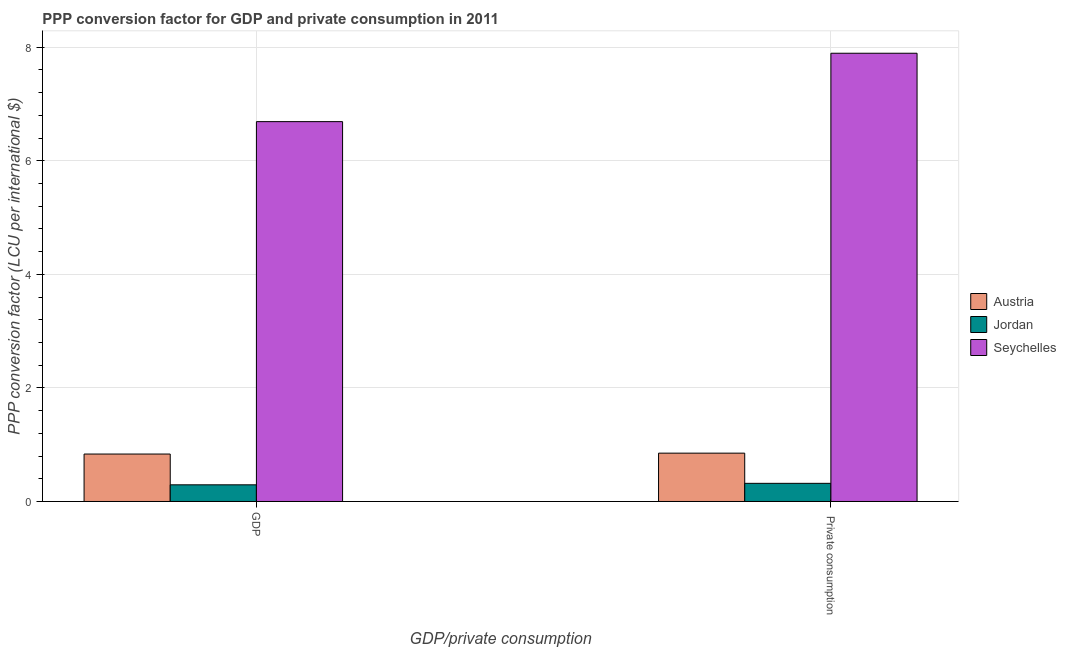How many different coloured bars are there?
Offer a very short reply. 3. Are the number of bars on each tick of the X-axis equal?
Make the answer very short. Yes. How many bars are there on the 2nd tick from the left?
Provide a short and direct response. 3. How many bars are there on the 1st tick from the right?
Provide a succinct answer. 3. What is the label of the 2nd group of bars from the left?
Your answer should be compact.  Private consumption. What is the ppp conversion factor for private consumption in Seychelles?
Make the answer very short. 7.9. Across all countries, what is the maximum ppp conversion factor for private consumption?
Offer a very short reply. 7.9. Across all countries, what is the minimum ppp conversion factor for gdp?
Offer a very short reply. 0.29. In which country was the ppp conversion factor for gdp maximum?
Provide a succinct answer. Seychelles. In which country was the ppp conversion factor for gdp minimum?
Keep it short and to the point. Jordan. What is the total ppp conversion factor for private consumption in the graph?
Offer a very short reply. 9.07. What is the difference between the ppp conversion factor for gdp in Jordan and that in Seychelles?
Ensure brevity in your answer.  -6.4. What is the difference between the ppp conversion factor for gdp in Jordan and the ppp conversion factor for private consumption in Seychelles?
Keep it short and to the point. -7.6. What is the average ppp conversion factor for private consumption per country?
Give a very brief answer. 3.02. What is the difference between the ppp conversion factor for private consumption and ppp conversion factor for gdp in Jordan?
Provide a short and direct response. 0.03. What is the ratio of the ppp conversion factor for private consumption in Austria to that in Seychelles?
Make the answer very short. 0.11. What does the 1st bar from the right in GDP represents?
Your response must be concise. Seychelles. How many bars are there?
Give a very brief answer. 6. Are all the bars in the graph horizontal?
Your answer should be compact. No. Are the values on the major ticks of Y-axis written in scientific E-notation?
Your answer should be very brief. No. Does the graph contain any zero values?
Make the answer very short. No. What is the title of the graph?
Ensure brevity in your answer.  PPP conversion factor for GDP and private consumption in 2011. What is the label or title of the X-axis?
Provide a succinct answer. GDP/private consumption. What is the label or title of the Y-axis?
Provide a succinct answer. PPP conversion factor (LCU per international $). What is the PPP conversion factor (LCU per international $) of Austria in GDP?
Offer a very short reply. 0.84. What is the PPP conversion factor (LCU per international $) of Jordan in GDP?
Your answer should be compact. 0.29. What is the PPP conversion factor (LCU per international $) of Seychelles in GDP?
Offer a very short reply. 6.69. What is the PPP conversion factor (LCU per international $) of Austria in  Private consumption?
Offer a terse response. 0.85. What is the PPP conversion factor (LCU per international $) in Jordan in  Private consumption?
Provide a short and direct response. 0.32. What is the PPP conversion factor (LCU per international $) of Seychelles in  Private consumption?
Offer a very short reply. 7.9. Across all GDP/private consumption, what is the maximum PPP conversion factor (LCU per international $) of Austria?
Keep it short and to the point. 0.85. Across all GDP/private consumption, what is the maximum PPP conversion factor (LCU per international $) of Jordan?
Offer a terse response. 0.32. Across all GDP/private consumption, what is the maximum PPP conversion factor (LCU per international $) in Seychelles?
Make the answer very short. 7.9. Across all GDP/private consumption, what is the minimum PPP conversion factor (LCU per international $) of Austria?
Provide a succinct answer. 0.84. Across all GDP/private consumption, what is the minimum PPP conversion factor (LCU per international $) in Jordan?
Ensure brevity in your answer.  0.29. Across all GDP/private consumption, what is the minimum PPP conversion factor (LCU per international $) in Seychelles?
Your answer should be very brief. 6.69. What is the total PPP conversion factor (LCU per international $) in Austria in the graph?
Keep it short and to the point. 1.69. What is the total PPP conversion factor (LCU per international $) in Jordan in the graph?
Make the answer very short. 0.61. What is the total PPP conversion factor (LCU per international $) in Seychelles in the graph?
Your answer should be very brief. 14.59. What is the difference between the PPP conversion factor (LCU per international $) of Austria in GDP and that in  Private consumption?
Make the answer very short. -0.02. What is the difference between the PPP conversion factor (LCU per international $) in Jordan in GDP and that in  Private consumption?
Keep it short and to the point. -0.03. What is the difference between the PPP conversion factor (LCU per international $) in Seychelles in GDP and that in  Private consumption?
Offer a terse response. -1.2. What is the difference between the PPP conversion factor (LCU per international $) of Austria in GDP and the PPP conversion factor (LCU per international $) of Jordan in  Private consumption?
Provide a short and direct response. 0.52. What is the difference between the PPP conversion factor (LCU per international $) in Austria in GDP and the PPP conversion factor (LCU per international $) in Seychelles in  Private consumption?
Offer a terse response. -7.06. What is the difference between the PPP conversion factor (LCU per international $) of Jordan in GDP and the PPP conversion factor (LCU per international $) of Seychelles in  Private consumption?
Make the answer very short. -7.6. What is the average PPP conversion factor (LCU per international $) of Austria per GDP/private consumption?
Make the answer very short. 0.84. What is the average PPP conversion factor (LCU per international $) of Jordan per GDP/private consumption?
Ensure brevity in your answer.  0.31. What is the average PPP conversion factor (LCU per international $) of Seychelles per GDP/private consumption?
Your response must be concise. 7.29. What is the difference between the PPP conversion factor (LCU per international $) of Austria and PPP conversion factor (LCU per international $) of Jordan in GDP?
Make the answer very short. 0.54. What is the difference between the PPP conversion factor (LCU per international $) in Austria and PPP conversion factor (LCU per international $) in Seychelles in GDP?
Your response must be concise. -5.86. What is the difference between the PPP conversion factor (LCU per international $) of Jordan and PPP conversion factor (LCU per international $) of Seychelles in GDP?
Offer a very short reply. -6.4. What is the difference between the PPP conversion factor (LCU per international $) of Austria and PPP conversion factor (LCU per international $) of Jordan in  Private consumption?
Offer a terse response. 0.53. What is the difference between the PPP conversion factor (LCU per international $) in Austria and PPP conversion factor (LCU per international $) in Seychelles in  Private consumption?
Ensure brevity in your answer.  -7.04. What is the difference between the PPP conversion factor (LCU per international $) in Jordan and PPP conversion factor (LCU per international $) in Seychelles in  Private consumption?
Offer a terse response. -7.58. What is the ratio of the PPP conversion factor (LCU per international $) of Austria in GDP to that in  Private consumption?
Your response must be concise. 0.98. What is the ratio of the PPP conversion factor (LCU per international $) in Jordan in GDP to that in  Private consumption?
Your response must be concise. 0.92. What is the ratio of the PPP conversion factor (LCU per international $) of Seychelles in GDP to that in  Private consumption?
Give a very brief answer. 0.85. What is the difference between the highest and the second highest PPP conversion factor (LCU per international $) in Austria?
Give a very brief answer. 0.02. What is the difference between the highest and the second highest PPP conversion factor (LCU per international $) of Jordan?
Offer a very short reply. 0.03. What is the difference between the highest and the second highest PPP conversion factor (LCU per international $) of Seychelles?
Keep it short and to the point. 1.2. What is the difference between the highest and the lowest PPP conversion factor (LCU per international $) of Austria?
Ensure brevity in your answer.  0.02. What is the difference between the highest and the lowest PPP conversion factor (LCU per international $) of Jordan?
Offer a terse response. 0.03. What is the difference between the highest and the lowest PPP conversion factor (LCU per international $) in Seychelles?
Keep it short and to the point. 1.2. 